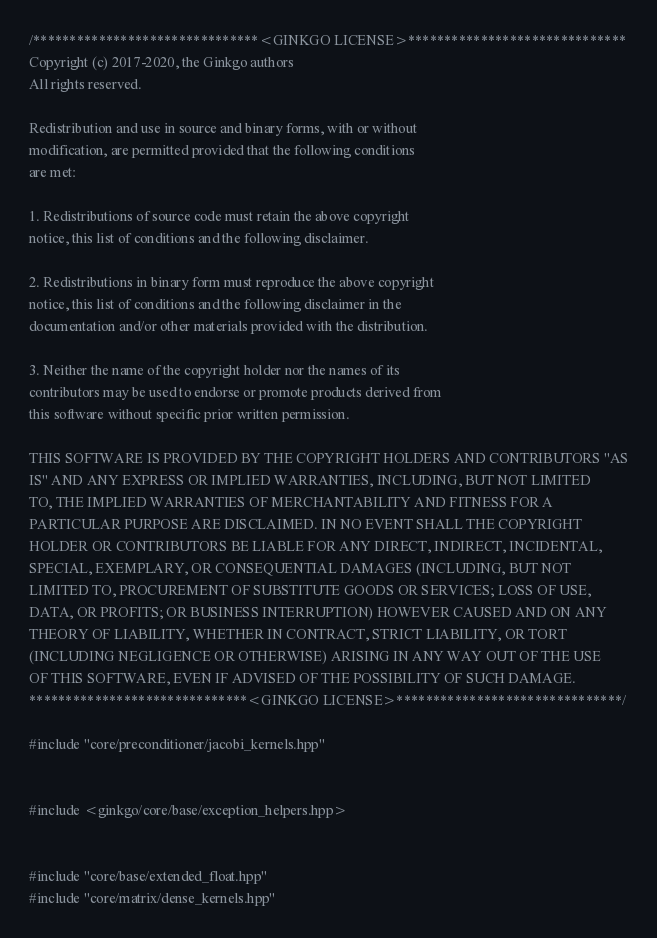Convert code to text. <code><loc_0><loc_0><loc_500><loc_500><_Cuda_>/*******************************<GINKGO LICENSE>******************************
Copyright (c) 2017-2020, the Ginkgo authors
All rights reserved.

Redistribution and use in source and binary forms, with or without
modification, are permitted provided that the following conditions
are met:

1. Redistributions of source code must retain the above copyright
notice, this list of conditions and the following disclaimer.

2. Redistributions in binary form must reproduce the above copyright
notice, this list of conditions and the following disclaimer in the
documentation and/or other materials provided with the distribution.

3. Neither the name of the copyright holder nor the names of its
contributors may be used to endorse or promote products derived from
this software without specific prior written permission.

THIS SOFTWARE IS PROVIDED BY THE COPYRIGHT HOLDERS AND CONTRIBUTORS "AS
IS" AND ANY EXPRESS OR IMPLIED WARRANTIES, INCLUDING, BUT NOT LIMITED
TO, THE IMPLIED WARRANTIES OF MERCHANTABILITY AND FITNESS FOR A
PARTICULAR PURPOSE ARE DISCLAIMED. IN NO EVENT SHALL THE COPYRIGHT
HOLDER OR CONTRIBUTORS BE LIABLE FOR ANY DIRECT, INDIRECT, INCIDENTAL,
SPECIAL, EXEMPLARY, OR CONSEQUENTIAL DAMAGES (INCLUDING, BUT NOT
LIMITED TO, PROCUREMENT OF SUBSTITUTE GOODS OR SERVICES; LOSS OF USE,
DATA, OR PROFITS; OR BUSINESS INTERRUPTION) HOWEVER CAUSED AND ON ANY
THEORY OF LIABILITY, WHETHER IN CONTRACT, STRICT LIABILITY, OR TORT
(INCLUDING NEGLIGENCE OR OTHERWISE) ARISING IN ANY WAY OUT OF THE USE
OF THIS SOFTWARE, EVEN IF ADVISED OF THE POSSIBILITY OF SUCH DAMAGE.
******************************<GINKGO LICENSE>*******************************/

#include "core/preconditioner/jacobi_kernels.hpp"


#include <ginkgo/core/base/exception_helpers.hpp>


#include "core/base/extended_float.hpp"
#include "core/matrix/dense_kernels.hpp"</code> 